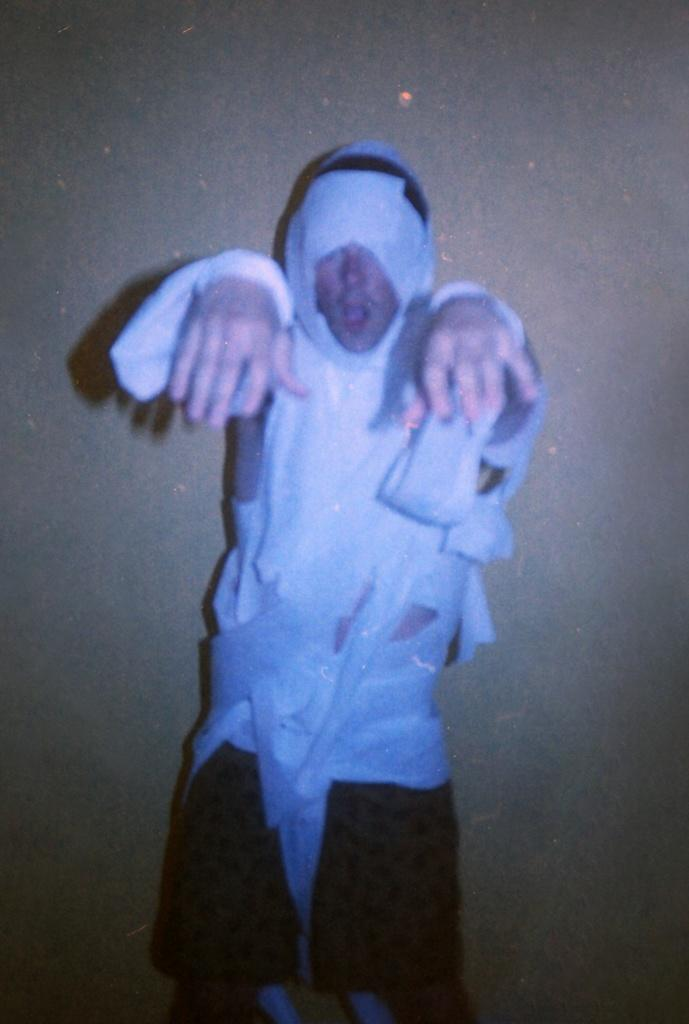What is the main subject of the image? There is a person in the image. Can you describe the person's attire? The person is wearing a white and black colored dress. How is the person described in the image? The person is described as stunning. What type of toys does the person have in the image? There is no mention of toys in the image, so it cannot be determined if the person has any toys. 